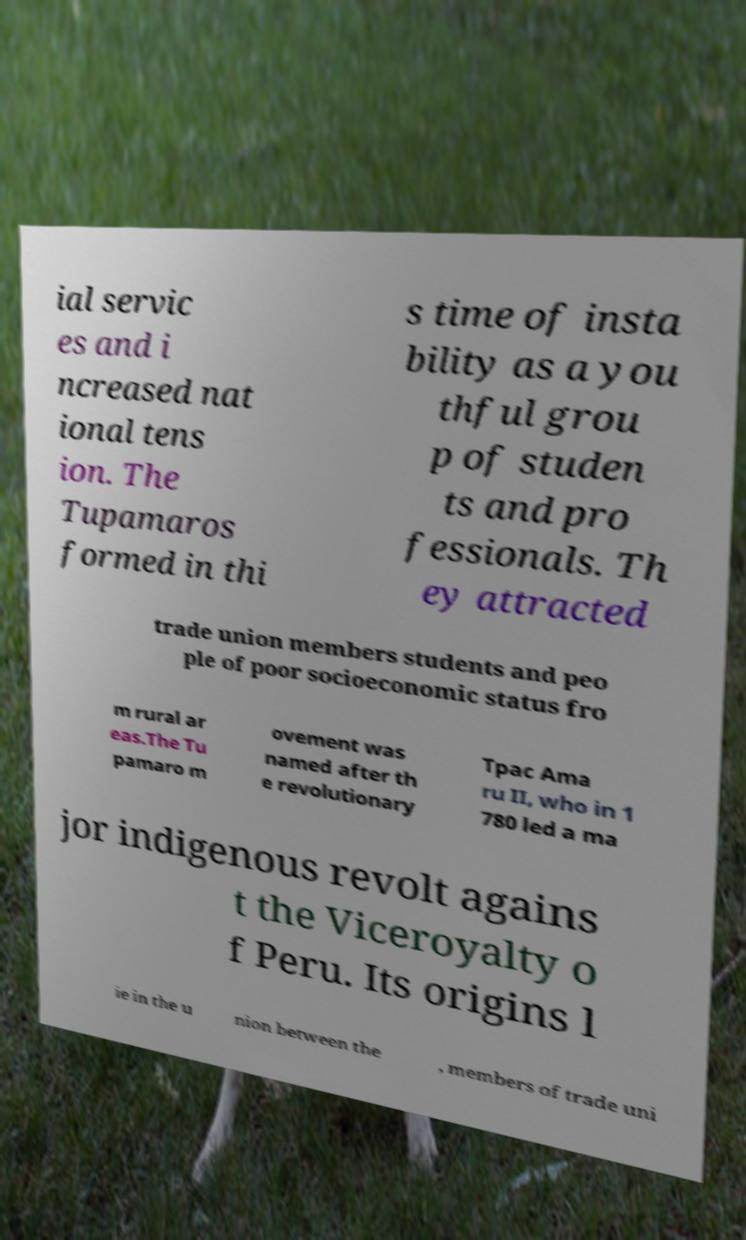Please identify and transcribe the text found in this image. ial servic es and i ncreased nat ional tens ion. The Tupamaros formed in thi s time of insta bility as a you thful grou p of studen ts and pro fessionals. Th ey attracted trade union members students and peo ple of poor socioeconomic status fro m rural ar eas.The Tu pamaro m ovement was named after th e revolutionary Tpac Ama ru II, who in 1 780 led a ma jor indigenous revolt agains t the Viceroyalty o f Peru. Its origins l ie in the u nion between the , members of trade uni 